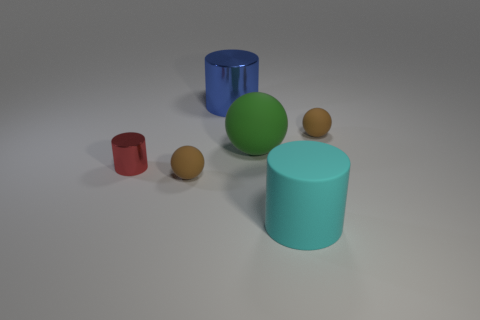Add 1 tiny objects. How many objects exist? 7 Add 6 big green matte balls. How many big green matte balls exist? 7 Subtract 0 blue cubes. How many objects are left? 6 Subtract all rubber things. Subtract all red rubber blocks. How many objects are left? 2 Add 1 blue things. How many blue things are left? 2 